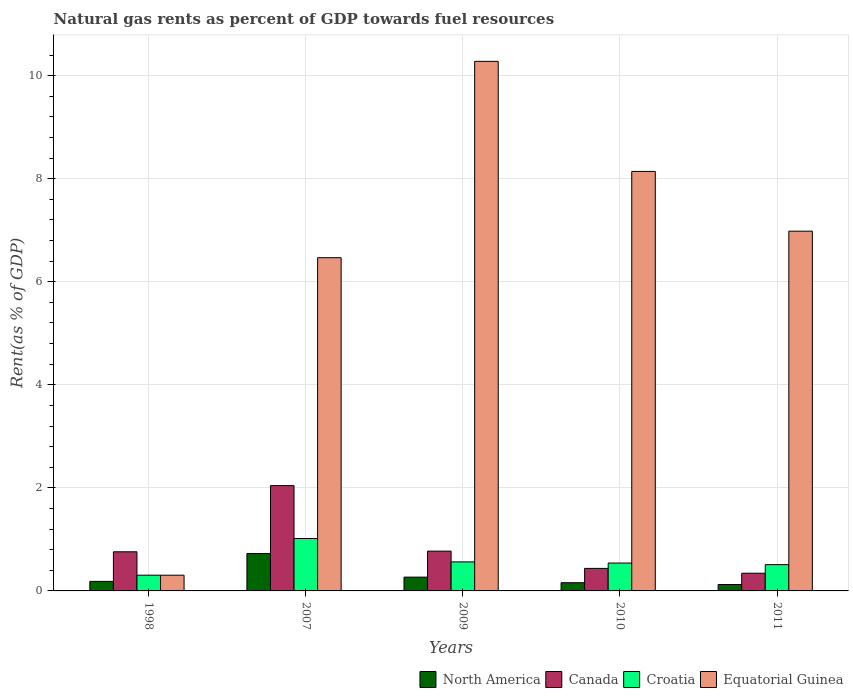How many groups of bars are there?
Your answer should be compact. 5. Are the number of bars per tick equal to the number of legend labels?
Your answer should be very brief. Yes. Are the number of bars on each tick of the X-axis equal?
Provide a short and direct response. Yes. What is the matural gas rent in Equatorial Guinea in 1998?
Offer a very short reply. 0.31. Across all years, what is the maximum matural gas rent in North America?
Keep it short and to the point. 0.73. Across all years, what is the minimum matural gas rent in Equatorial Guinea?
Offer a very short reply. 0.31. In which year was the matural gas rent in North America maximum?
Your response must be concise. 2007. In which year was the matural gas rent in Equatorial Guinea minimum?
Provide a short and direct response. 1998. What is the total matural gas rent in North America in the graph?
Your answer should be compact. 1.46. What is the difference between the matural gas rent in North America in 2007 and that in 2009?
Offer a very short reply. 0.46. What is the difference between the matural gas rent in Canada in 2011 and the matural gas rent in Equatorial Guinea in 2010?
Give a very brief answer. -7.8. What is the average matural gas rent in Equatorial Guinea per year?
Provide a succinct answer. 6.43. In the year 2009, what is the difference between the matural gas rent in Canada and matural gas rent in Equatorial Guinea?
Give a very brief answer. -9.5. What is the ratio of the matural gas rent in Equatorial Guinea in 1998 to that in 2011?
Keep it short and to the point. 0.04. Is the matural gas rent in Canada in 1998 less than that in 2010?
Make the answer very short. No. Is the difference between the matural gas rent in Canada in 2007 and 2011 greater than the difference between the matural gas rent in Equatorial Guinea in 2007 and 2011?
Keep it short and to the point. Yes. What is the difference between the highest and the second highest matural gas rent in Canada?
Offer a terse response. 1.27. What is the difference between the highest and the lowest matural gas rent in North America?
Ensure brevity in your answer.  0.6. Is the sum of the matural gas rent in Canada in 2010 and 2011 greater than the maximum matural gas rent in Equatorial Guinea across all years?
Your response must be concise. No. Is it the case that in every year, the sum of the matural gas rent in Canada and matural gas rent in Equatorial Guinea is greater than the sum of matural gas rent in North America and matural gas rent in Croatia?
Keep it short and to the point. No. What does the 3rd bar from the left in 2011 represents?
Ensure brevity in your answer.  Croatia. Is it the case that in every year, the sum of the matural gas rent in Croatia and matural gas rent in North America is greater than the matural gas rent in Equatorial Guinea?
Give a very brief answer. No. Are all the bars in the graph horizontal?
Your answer should be very brief. No. How many years are there in the graph?
Give a very brief answer. 5. Does the graph contain grids?
Provide a short and direct response. Yes. Where does the legend appear in the graph?
Offer a terse response. Bottom right. What is the title of the graph?
Your answer should be compact. Natural gas rents as percent of GDP towards fuel resources. What is the label or title of the X-axis?
Your answer should be very brief. Years. What is the label or title of the Y-axis?
Give a very brief answer. Rent(as % of GDP). What is the Rent(as % of GDP) in North America in 1998?
Your response must be concise. 0.19. What is the Rent(as % of GDP) of Canada in 1998?
Offer a terse response. 0.76. What is the Rent(as % of GDP) in Croatia in 1998?
Offer a very short reply. 0.31. What is the Rent(as % of GDP) in Equatorial Guinea in 1998?
Give a very brief answer. 0.31. What is the Rent(as % of GDP) of North America in 2007?
Provide a short and direct response. 0.73. What is the Rent(as % of GDP) in Canada in 2007?
Offer a terse response. 2.04. What is the Rent(as % of GDP) of Croatia in 2007?
Provide a succinct answer. 1.02. What is the Rent(as % of GDP) of Equatorial Guinea in 2007?
Give a very brief answer. 6.47. What is the Rent(as % of GDP) in North America in 2009?
Your answer should be very brief. 0.27. What is the Rent(as % of GDP) in Canada in 2009?
Keep it short and to the point. 0.77. What is the Rent(as % of GDP) of Croatia in 2009?
Make the answer very short. 0.56. What is the Rent(as % of GDP) in Equatorial Guinea in 2009?
Give a very brief answer. 10.28. What is the Rent(as % of GDP) of North America in 2010?
Your answer should be compact. 0.16. What is the Rent(as % of GDP) in Canada in 2010?
Keep it short and to the point. 0.44. What is the Rent(as % of GDP) of Croatia in 2010?
Ensure brevity in your answer.  0.54. What is the Rent(as % of GDP) in Equatorial Guinea in 2010?
Offer a terse response. 8.14. What is the Rent(as % of GDP) of North America in 2011?
Ensure brevity in your answer.  0.12. What is the Rent(as % of GDP) in Canada in 2011?
Keep it short and to the point. 0.34. What is the Rent(as % of GDP) of Croatia in 2011?
Your response must be concise. 0.51. What is the Rent(as % of GDP) in Equatorial Guinea in 2011?
Give a very brief answer. 6.98. Across all years, what is the maximum Rent(as % of GDP) of North America?
Provide a short and direct response. 0.73. Across all years, what is the maximum Rent(as % of GDP) in Canada?
Provide a succinct answer. 2.04. Across all years, what is the maximum Rent(as % of GDP) in Croatia?
Offer a very short reply. 1.02. Across all years, what is the maximum Rent(as % of GDP) in Equatorial Guinea?
Offer a very short reply. 10.28. Across all years, what is the minimum Rent(as % of GDP) of North America?
Provide a short and direct response. 0.12. Across all years, what is the minimum Rent(as % of GDP) of Canada?
Ensure brevity in your answer.  0.34. Across all years, what is the minimum Rent(as % of GDP) in Croatia?
Give a very brief answer. 0.31. Across all years, what is the minimum Rent(as % of GDP) of Equatorial Guinea?
Provide a succinct answer. 0.31. What is the total Rent(as % of GDP) in North America in the graph?
Your response must be concise. 1.46. What is the total Rent(as % of GDP) of Canada in the graph?
Provide a succinct answer. 4.36. What is the total Rent(as % of GDP) in Croatia in the graph?
Make the answer very short. 2.94. What is the total Rent(as % of GDP) in Equatorial Guinea in the graph?
Your response must be concise. 32.17. What is the difference between the Rent(as % of GDP) of North America in 1998 and that in 2007?
Make the answer very short. -0.54. What is the difference between the Rent(as % of GDP) of Canada in 1998 and that in 2007?
Provide a short and direct response. -1.28. What is the difference between the Rent(as % of GDP) in Croatia in 1998 and that in 2007?
Make the answer very short. -0.71. What is the difference between the Rent(as % of GDP) of Equatorial Guinea in 1998 and that in 2007?
Your answer should be very brief. -6.16. What is the difference between the Rent(as % of GDP) of North America in 1998 and that in 2009?
Your response must be concise. -0.08. What is the difference between the Rent(as % of GDP) of Canada in 1998 and that in 2009?
Your answer should be compact. -0.01. What is the difference between the Rent(as % of GDP) of Croatia in 1998 and that in 2009?
Your answer should be very brief. -0.26. What is the difference between the Rent(as % of GDP) of Equatorial Guinea in 1998 and that in 2009?
Your answer should be very brief. -9.97. What is the difference between the Rent(as % of GDP) in North America in 1998 and that in 2010?
Offer a terse response. 0.03. What is the difference between the Rent(as % of GDP) of Canada in 1998 and that in 2010?
Give a very brief answer. 0.32. What is the difference between the Rent(as % of GDP) of Croatia in 1998 and that in 2010?
Give a very brief answer. -0.24. What is the difference between the Rent(as % of GDP) of Equatorial Guinea in 1998 and that in 2010?
Your response must be concise. -7.84. What is the difference between the Rent(as % of GDP) of North America in 1998 and that in 2011?
Offer a very short reply. 0.06. What is the difference between the Rent(as % of GDP) in Canada in 1998 and that in 2011?
Ensure brevity in your answer.  0.42. What is the difference between the Rent(as % of GDP) in Croatia in 1998 and that in 2011?
Offer a very short reply. -0.2. What is the difference between the Rent(as % of GDP) of Equatorial Guinea in 1998 and that in 2011?
Offer a terse response. -6.68. What is the difference between the Rent(as % of GDP) of North America in 2007 and that in 2009?
Provide a short and direct response. 0.46. What is the difference between the Rent(as % of GDP) of Canada in 2007 and that in 2009?
Make the answer very short. 1.27. What is the difference between the Rent(as % of GDP) of Croatia in 2007 and that in 2009?
Your answer should be very brief. 0.45. What is the difference between the Rent(as % of GDP) in Equatorial Guinea in 2007 and that in 2009?
Offer a very short reply. -3.81. What is the difference between the Rent(as % of GDP) in North America in 2007 and that in 2010?
Your answer should be very brief. 0.57. What is the difference between the Rent(as % of GDP) of Canada in 2007 and that in 2010?
Your response must be concise. 1.61. What is the difference between the Rent(as % of GDP) of Croatia in 2007 and that in 2010?
Make the answer very short. 0.48. What is the difference between the Rent(as % of GDP) in Equatorial Guinea in 2007 and that in 2010?
Your answer should be compact. -1.67. What is the difference between the Rent(as % of GDP) in North America in 2007 and that in 2011?
Your answer should be very brief. 0.6. What is the difference between the Rent(as % of GDP) of Canada in 2007 and that in 2011?
Your answer should be very brief. 1.7. What is the difference between the Rent(as % of GDP) of Croatia in 2007 and that in 2011?
Make the answer very short. 0.51. What is the difference between the Rent(as % of GDP) in Equatorial Guinea in 2007 and that in 2011?
Offer a terse response. -0.51. What is the difference between the Rent(as % of GDP) in North America in 2009 and that in 2010?
Keep it short and to the point. 0.11. What is the difference between the Rent(as % of GDP) in Canada in 2009 and that in 2010?
Provide a short and direct response. 0.34. What is the difference between the Rent(as % of GDP) in Croatia in 2009 and that in 2010?
Ensure brevity in your answer.  0.02. What is the difference between the Rent(as % of GDP) in Equatorial Guinea in 2009 and that in 2010?
Your response must be concise. 2.14. What is the difference between the Rent(as % of GDP) of North America in 2009 and that in 2011?
Your answer should be compact. 0.14. What is the difference between the Rent(as % of GDP) of Canada in 2009 and that in 2011?
Ensure brevity in your answer.  0.43. What is the difference between the Rent(as % of GDP) in Croatia in 2009 and that in 2011?
Your response must be concise. 0.05. What is the difference between the Rent(as % of GDP) of Equatorial Guinea in 2009 and that in 2011?
Ensure brevity in your answer.  3.3. What is the difference between the Rent(as % of GDP) in North America in 2010 and that in 2011?
Give a very brief answer. 0.03. What is the difference between the Rent(as % of GDP) in Canada in 2010 and that in 2011?
Make the answer very short. 0.09. What is the difference between the Rent(as % of GDP) in Croatia in 2010 and that in 2011?
Provide a succinct answer. 0.03. What is the difference between the Rent(as % of GDP) in Equatorial Guinea in 2010 and that in 2011?
Offer a terse response. 1.16. What is the difference between the Rent(as % of GDP) in North America in 1998 and the Rent(as % of GDP) in Canada in 2007?
Offer a very short reply. -1.86. What is the difference between the Rent(as % of GDP) of North America in 1998 and the Rent(as % of GDP) of Croatia in 2007?
Ensure brevity in your answer.  -0.83. What is the difference between the Rent(as % of GDP) in North America in 1998 and the Rent(as % of GDP) in Equatorial Guinea in 2007?
Your answer should be compact. -6.28. What is the difference between the Rent(as % of GDP) in Canada in 1998 and the Rent(as % of GDP) in Croatia in 2007?
Offer a terse response. -0.26. What is the difference between the Rent(as % of GDP) in Canada in 1998 and the Rent(as % of GDP) in Equatorial Guinea in 2007?
Give a very brief answer. -5.71. What is the difference between the Rent(as % of GDP) of Croatia in 1998 and the Rent(as % of GDP) of Equatorial Guinea in 2007?
Give a very brief answer. -6.16. What is the difference between the Rent(as % of GDP) of North America in 1998 and the Rent(as % of GDP) of Canada in 2009?
Give a very brief answer. -0.59. What is the difference between the Rent(as % of GDP) of North America in 1998 and the Rent(as % of GDP) of Croatia in 2009?
Make the answer very short. -0.38. What is the difference between the Rent(as % of GDP) of North America in 1998 and the Rent(as % of GDP) of Equatorial Guinea in 2009?
Your answer should be compact. -10.09. What is the difference between the Rent(as % of GDP) of Canada in 1998 and the Rent(as % of GDP) of Croatia in 2009?
Provide a succinct answer. 0.2. What is the difference between the Rent(as % of GDP) in Canada in 1998 and the Rent(as % of GDP) in Equatorial Guinea in 2009?
Offer a very short reply. -9.52. What is the difference between the Rent(as % of GDP) in Croatia in 1998 and the Rent(as % of GDP) in Equatorial Guinea in 2009?
Your answer should be very brief. -9.97. What is the difference between the Rent(as % of GDP) of North America in 1998 and the Rent(as % of GDP) of Canada in 2010?
Keep it short and to the point. -0.25. What is the difference between the Rent(as % of GDP) of North America in 1998 and the Rent(as % of GDP) of Croatia in 2010?
Ensure brevity in your answer.  -0.36. What is the difference between the Rent(as % of GDP) of North America in 1998 and the Rent(as % of GDP) of Equatorial Guinea in 2010?
Your answer should be compact. -7.96. What is the difference between the Rent(as % of GDP) in Canada in 1998 and the Rent(as % of GDP) in Croatia in 2010?
Your response must be concise. 0.22. What is the difference between the Rent(as % of GDP) of Canada in 1998 and the Rent(as % of GDP) of Equatorial Guinea in 2010?
Your response must be concise. -7.38. What is the difference between the Rent(as % of GDP) in Croatia in 1998 and the Rent(as % of GDP) in Equatorial Guinea in 2010?
Your response must be concise. -7.84. What is the difference between the Rent(as % of GDP) in North America in 1998 and the Rent(as % of GDP) in Canada in 2011?
Your answer should be compact. -0.16. What is the difference between the Rent(as % of GDP) in North America in 1998 and the Rent(as % of GDP) in Croatia in 2011?
Provide a succinct answer. -0.33. What is the difference between the Rent(as % of GDP) of North America in 1998 and the Rent(as % of GDP) of Equatorial Guinea in 2011?
Your response must be concise. -6.8. What is the difference between the Rent(as % of GDP) of Canada in 1998 and the Rent(as % of GDP) of Croatia in 2011?
Ensure brevity in your answer.  0.25. What is the difference between the Rent(as % of GDP) in Canada in 1998 and the Rent(as % of GDP) in Equatorial Guinea in 2011?
Offer a very short reply. -6.22. What is the difference between the Rent(as % of GDP) in Croatia in 1998 and the Rent(as % of GDP) in Equatorial Guinea in 2011?
Your response must be concise. -6.68. What is the difference between the Rent(as % of GDP) in North America in 2007 and the Rent(as % of GDP) in Canada in 2009?
Ensure brevity in your answer.  -0.05. What is the difference between the Rent(as % of GDP) in North America in 2007 and the Rent(as % of GDP) in Croatia in 2009?
Your answer should be very brief. 0.16. What is the difference between the Rent(as % of GDP) of North America in 2007 and the Rent(as % of GDP) of Equatorial Guinea in 2009?
Your response must be concise. -9.55. What is the difference between the Rent(as % of GDP) of Canada in 2007 and the Rent(as % of GDP) of Croatia in 2009?
Your answer should be very brief. 1.48. What is the difference between the Rent(as % of GDP) in Canada in 2007 and the Rent(as % of GDP) in Equatorial Guinea in 2009?
Make the answer very short. -8.23. What is the difference between the Rent(as % of GDP) in Croatia in 2007 and the Rent(as % of GDP) in Equatorial Guinea in 2009?
Your answer should be compact. -9.26. What is the difference between the Rent(as % of GDP) in North America in 2007 and the Rent(as % of GDP) in Canada in 2010?
Keep it short and to the point. 0.29. What is the difference between the Rent(as % of GDP) of North America in 2007 and the Rent(as % of GDP) of Croatia in 2010?
Keep it short and to the point. 0.19. What is the difference between the Rent(as % of GDP) of North America in 2007 and the Rent(as % of GDP) of Equatorial Guinea in 2010?
Keep it short and to the point. -7.41. What is the difference between the Rent(as % of GDP) in Canada in 2007 and the Rent(as % of GDP) in Croatia in 2010?
Keep it short and to the point. 1.5. What is the difference between the Rent(as % of GDP) in Canada in 2007 and the Rent(as % of GDP) in Equatorial Guinea in 2010?
Make the answer very short. -6.1. What is the difference between the Rent(as % of GDP) in Croatia in 2007 and the Rent(as % of GDP) in Equatorial Guinea in 2010?
Offer a very short reply. -7.12. What is the difference between the Rent(as % of GDP) in North America in 2007 and the Rent(as % of GDP) in Canada in 2011?
Keep it short and to the point. 0.38. What is the difference between the Rent(as % of GDP) in North America in 2007 and the Rent(as % of GDP) in Croatia in 2011?
Make the answer very short. 0.22. What is the difference between the Rent(as % of GDP) in North America in 2007 and the Rent(as % of GDP) in Equatorial Guinea in 2011?
Ensure brevity in your answer.  -6.26. What is the difference between the Rent(as % of GDP) in Canada in 2007 and the Rent(as % of GDP) in Croatia in 2011?
Your response must be concise. 1.53. What is the difference between the Rent(as % of GDP) in Canada in 2007 and the Rent(as % of GDP) in Equatorial Guinea in 2011?
Make the answer very short. -4.94. What is the difference between the Rent(as % of GDP) in Croatia in 2007 and the Rent(as % of GDP) in Equatorial Guinea in 2011?
Your response must be concise. -5.96. What is the difference between the Rent(as % of GDP) in North America in 2009 and the Rent(as % of GDP) in Canada in 2010?
Make the answer very short. -0.17. What is the difference between the Rent(as % of GDP) of North America in 2009 and the Rent(as % of GDP) of Croatia in 2010?
Provide a succinct answer. -0.27. What is the difference between the Rent(as % of GDP) of North America in 2009 and the Rent(as % of GDP) of Equatorial Guinea in 2010?
Give a very brief answer. -7.87. What is the difference between the Rent(as % of GDP) of Canada in 2009 and the Rent(as % of GDP) of Croatia in 2010?
Your response must be concise. 0.23. What is the difference between the Rent(as % of GDP) in Canada in 2009 and the Rent(as % of GDP) in Equatorial Guinea in 2010?
Offer a very short reply. -7.37. What is the difference between the Rent(as % of GDP) of Croatia in 2009 and the Rent(as % of GDP) of Equatorial Guinea in 2010?
Ensure brevity in your answer.  -7.58. What is the difference between the Rent(as % of GDP) of North America in 2009 and the Rent(as % of GDP) of Canada in 2011?
Give a very brief answer. -0.08. What is the difference between the Rent(as % of GDP) of North America in 2009 and the Rent(as % of GDP) of Croatia in 2011?
Offer a terse response. -0.24. What is the difference between the Rent(as % of GDP) in North America in 2009 and the Rent(as % of GDP) in Equatorial Guinea in 2011?
Provide a short and direct response. -6.71. What is the difference between the Rent(as % of GDP) of Canada in 2009 and the Rent(as % of GDP) of Croatia in 2011?
Your answer should be compact. 0.26. What is the difference between the Rent(as % of GDP) in Canada in 2009 and the Rent(as % of GDP) in Equatorial Guinea in 2011?
Provide a succinct answer. -6.21. What is the difference between the Rent(as % of GDP) of Croatia in 2009 and the Rent(as % of GDP) of Equatorial Guinea in 2011?
Provide a succinct answer. -6.42. What is the difference between the Rent(as % of GDP) in North America in 2010 and the Rent(as % of GDP) in Canada in 2011?
Make the answer very short. -0.18. What is the difference between the Rent(as % of GDP) in North America in 2010 and the Rent(as % of GDP) in Croatia in 2011?
Offer a terse response. -0.35. What is the difference between the Rent(as % of GDP) of North America in 2010 and the Rent(as % of GDP) of Equatorial Guinea in 2011?
Your response must be concise. -6.82. What is the difference between the Rent(as % of GDP) in Canada in 2010 and the Rent(as % of GDP) in Croatia in 2011?
Give a very brief answer. -0.07. What is the difference between the Rent(as % of GDP) in Canada in 2010 and the Rent(as % of GDP) in Equatorial Guinea in 2011?
Make the answer very short. -6.54. What is the difference between the Rent(as % of GDP) of Croatia in 2010 and the Rent(as % of GDP) of Equatorial Guinea in 2011?
Make the answer very short. -6.44. What is the average Rent(as % of GDP) of North America per year?
Keep it short and to the point. 0.29. What is the average Rent(as % of GDP) in Canada per year?
Ensure brevity in your answer.  0.87. What is the average Rent(as % of GDP) in Croatia per year?
Your answer should be very brief. 0.59. What is the average Rent(as % of GDP) of Equatorial Guinea per year?
Ensure brevity in your answer.  6.43. In the year 1998, what is the difference between the Rent(as % of GDP) in North America and Rent(as % of GDP) in Canada?
Give a very brief answer. -0.57. In the year 1998, what is the difference between the Rent(as % of GDP) of North America and Rent(as % of GDP) of Croatia?
Ensure brevity in your answer.  -0.12. In the year 1998, what is the difference between the Rent(as % of GDP) of North America and Rent(as % of GDP) of Equatorial Guinea?
Offer a terse response. -0.12. In the year 1998, what is the difference between the Rent(as % of GDP) in Canada and Rent(as % of GDP) in Croatia?
Make the answer very short. 0.45. In the year 1998, what is the difference between the Rent(as % of GDP) in Canada and Rent(as % of GDP) in Equatorial Guinea?
Make the answer very short. 0.45. In the year 2007, what is the difference between the Rent(as % of GDP) of North America and Rent(as % of GDP) of Canada?
Your response must be concise. -1.32. In the year 2007, what is the difference between the Rent(as % of GDP) in North America and Rent(as % of GDP) in Croatia?
Your answer should be very brief. -0.29. In the year 2007, what is the difference between the Rent(as % of GDP) in North America and Rent(as % of GDP) in Equatorial Guinea?
Offer a terse response. -5.74. In the year 2007, what is the difference between the Rent(as % of GDP) in Canada and Rent(as % of GDP) in Croatia?
Make the answer very short. 1.03. In the year 2007, what is the difference between the Rent(as % of GDP) in Canada and Rent(as % of GDP) in Equatorial Guinea?
Make the answer very short. -4.42. In the year 2007, what is the difference between the Rent(as % of GDP) of Croatia and Rent(as % of GDP) of Equatorial Guinea?
Provide a succinct answer. -5.45. In the year 2009, what is the difference between the Rent(as % of GDP) of North America and Rent(as % of GDP) of Canada?
Give a very brief answer. -0.5. In the year 2009, what is the difference between the Rent(as % of GDP) in North America and Rent(as % of GDP) in Croatia?
Your response must be concise. -0.3. In the year 2009, what is the difference between the Rent(as % of GDP) in North America and Rent(as % of GDP) in Equatorial Guinea?
Provide a succinct answer. -10.01. In the year 2009, what is the difference between the Rent(as % of GDP) in Canada and Rent(as % of GDP) in Croatia?
Offer a terse response. 0.21. In the year 2009, what is the difference between the Rent(as % of GDP) in Canada and Rent(as % of GDP) in Equatorial Guinea?
Ensure brevity in your answer.  -9.5. In the year 2009, what is the difference between the Rent(as % of GDP) in Croatia and Rent(as % of GDP) in Equatorial Guinea?
Ensure brevity in your answer.  -9.71. In the year 2010, what is the difference between the Rent(as % of GDP) of North America and Rent(as % of GDP) of Canada?
Offer a very short reply. -0.28. In the year 2010, what is the difference between the Rent(as % of GDP) of North America and Rent(as % of GDP) of Croatia?
Your response must be concise. -0.38. In the year 2010, what is the difference between the Rent(as % of GDP) in North America and Rent(as % of GDP) in Equatorial Guinea?
Offer a terse response. -7.98. In the year 2010, what is the difference between the Rent(as % of GDP) of Canada and Rent(as % of GDP) of Croatia?
Give a very brief answer. -0.1. In the year 2010, what is the difference between the Rent(as % of GDP) of Canada and Rent(as % of GDP) of Equatorial Guinea?
Keep it short and to the point. -7.7. In the year 2010, what is the difference between the Rent(as % of GDP) in Croatia and Rent(as % of GDP) in Equatorial Guinea?
Your answer should be compact. -7.6. In the year 2011, what is the difference between the Rent(as % of GDP) in North America and Rent(as % of GDP) in Canada?
Keep it short and to the point. -0.22. In the year 2011, what is the difference between the Rent(as % of GDP) of North America and Rent(as % of GDP) of Croatia?
Ensure brevity in your answer.  -0.39. In the year 2011, what is the difference between the Rent(as % of GDP) in North America and Rent(as % of GDP) in Equatorial Guinea?
Provide a succinct answer. -6.86. In the year 2011, what is the difference between the Rent(as % of GDP) of Canada and Rent(as % of GDP) of Croatia?
Give a very brief answer. -0.17. In the year 2011, what is the difference between the Rent(as % of GDP) of Canada and Rent(as % of GDP) of Equatorial Guinea?
Your answer should be very brief. -6.64. In the year 2011, what is the difference between the Rent(as % of GDP) in Croatia and Rent(as % of GDP) in Equatorial Guinea?
Ensure brevity in your answer.  -6.47. What is the ratio of the Rent(as % of GDP) in North America in 1998 to that in 2007?
Ensure brevity in your answer.  0.25. What is the ratio of the Rent(as % of GDP) in Canada in 1998 to that in 2007?
Provide a short and direct response. 0.37. What is the ratio of the Rent(as % of GDP) in Croatia in 1998 to that in 2007?
Your answer should be compact. 0.3. What is the ratio of the Rent(as % of GDP) in Equatorial Guinea in 1998 to that in 2007?
Your answer should be very brief. 0.05. What is the ratio of the Rent(as % of GDP) in North America in 1998 to that in 2009?
Your response must be concise. 0.69. What is the ratio of the Rent(as % of GDP) in Canada in 1998 to that in 2009?
Provide a succinct answer. 0.98. What is the ratio of the Rent(as % of GDP) of Croatia in 1998 to that in 2009?
Provide a succinct answer. 0.54. What is the ratio of the Rent(as % of GDP) in Equatorial Guinea in 1998 to that in 2009?
Keep it short and to the point. 0.03. What is the ratio of the Rent(as % of GDP) of North America in 1998 to that in 2010?
Provide a succinct answer. 1.16. What is the ratio of the Rent(as % of GDP) in Canada in 1998 to that in 2010?
Give a very brief answer. 1.74. What is the ratio of the Rent(as % of GDP) in Croatia in 1998 to that in 2010?
Your answer should be compact. 0.56. What is the ratio of the Rent(as % of GDP) of Equatorial Guinea in 1998 to that in 2010?
Give a very brief answer. 0.04. What is the ratio of the Rent(as % of GDP) of North America in 1998 to that in 2011?
Make the answer very short. 1.49. What is the ratio of the Rent(as % of GDP) of Canada in 1998 to that in 2011?
Provide a succinct answer. 2.21. What is the ratio of the Rent(as % of GDP) of Croatia in 1998 to that in 2011?
Offer a very short reply. 0.6. What is the ratio of the Rent(as % of GDP) of Equatorial Guinea in 1998 to that in 2011?
Ensure brevity in your answer.  0.04. What is the ratio of the Rent(as % of GDP) in North America in 2007 to that in 2009?
Keep it short and to the point. 2.71. What is the ratio of the Rent(as % of GDP) of Canada in 2007 to that in 2009?
Provide a short and direct response. 2.65. What is the ratio of the Rent(as % of GDP) in Croatia in 2007 to that in 2009?
Ensure brevity in your answer.  1.8. What is the ratio of the Rent(as % of GDP) in Equatorial Guinea in 2007 to that in 2009?
Give a very brief answer. 0.63. What is the ratio of the Rent(as % of GDP) of North America in 2007 to that in 2010?
Provide a succinct answer. 4.56. What is the ratio of the Rent(as % of GDP) of Canada in 2007 to that in 2010?
Offer a very short reply. 4.68. What is the ratio of the Rent(as % of GDP) in Croatia in 2007 to that in 2010?
Offer a very short reply. 1.88. What is the ratio of the Rent(as % of GDP) of Equatorial Guinea in 2007 to that in 2010?
Provide a succinct answer. 0.79. What is the ratio of the Rent(as % of GDP) of North America in 2007 to that in 2011?
Your answer should be compact. 5.84. What is the ratio of the Rent(as % of GDP) in Canada in 2007 to that in 2011?
Keep it short and to the point. 5.94. What is the ratio of the Rent(as % of GDP) in Croatia in 2007 to that in 2011?
Your response must be concise. 1.99. What is the ratio of the Rent(as % of GDP) in Equatorial Guinea in 2007 to that in 2011?
Give a very brief answer. 0.93. What is the ratio of the Rent(as % of GDP) of North America in 2009 to that in 2010?
Offer a terse response. 1.68. What is the ratio of the Rent(as % of GDP) of Canada in 2009 to that in 2010?
Your response must be concise. 1.77. What is the ratio of the Rent(as % of GDP) of Croatia in 2009 to that in 2010?
Offer a terse response. 1.04. What is the ratio of the Rent(as % of GDP) of Equatorial Guinea in 2009 to that in 2010?
Make the answer very short. 1.26. What is the ratio of the Rent(as % of GDP) in North America in 2009 to that in 2011?
Keep it short and to the point. 2.15. What is the ratio of the Rent(as % of GDP) of Canada in 2009 to that in 2011?
Your response must be concise. 2.25. What is the ratio of the Rent(as % of GDP) in Croatia in 2009 to that in 2011?
Make the answer very short. 1.1. What is the ratio of the Rent(as % of GDP) in Equatorial Guinea in 2009 to that in 2011?
Make the answer very short. 1.47. What is the ratio of the Rent(as % of GDP) of North America in 2010 to that in 2011?
Your answer should be very brief. 1.28. What is the ratio of the Rent(as % of GDP) in Canada in 2010 to that in 2011?
Your answer should be compact. 1.27. What is the ratio of the Rent(as % of GDP) in Croatia in 2010 to that in 2011?
Make the answer very short. 1.06. What is the ratio of the Rent(as % of GDP) in Equatorial Guinea in 2010 to that in 2011?
Your response must be concise. 1.17. What is the difference between the highest and the second highest Rent(as % of GDP) of North America?
Give a very brief answer. 0.46. What is the difference between the highest and the second highest Rent(as % of GDP) of Canada?
Give a very brief answer. 1.27. What is the difference between the highest and the second highest Rent(as % of GDP) of Croatia?
Provide a succinct answer. 0.45. What is the difference between the highest and the second highest Rent(as % of GDP) in Equatorial Guinea?
Offer a very short reply. 2.14. What is the difference between the highest and the lowest Rent(as % of GDP) in North America?
Your answer should be compact. 0.6. What is the difference between the highest and the lowest Rent(as % of GDP) of Canada?
Your answer should be very brief. 1.7. What is the difference between the highest and the lowest Rent(as % of GDP) of Croatia?
Offer a very short reply. 0.71. What is the difference between the highest and the lowest Rent(as % of GDP) of Equatorial Guinea?
Offer a very short reply. 9.97. 